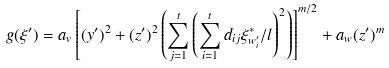Convert formula to latex. <formula><loc_0><loc_0><loc_500><loc_500>g ( \xi ^ { \prime } ) = a _ { v } \left [ ( y ^ { \prime } ) ^ { 2 } + ( z ^ { \prime } ) ^ { 2 } \left ( \sum _ { j = 1 } ^ { t } \left ( \sum _ { i = 1 } ^ { t } d _ { i j } \xi _ { w _ { i } ^ { \prime } } ^ { \ast } / l \right ) ^ { 2 } \right ) \right ] ^ { m / 2 } + a _ { w } ( z ^ { \prime } ) ^ { m }</formula> 